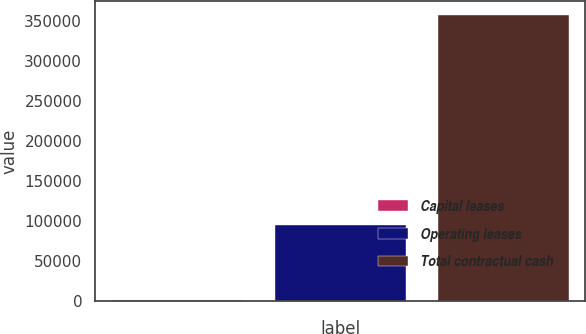Convert chart. <chart><loc_0><loc_0><loc_500><loc_500><bar_chart><fcel>Capital leases<fcel>Operating leases<fcel>Total contractual cash<nl><fcel>1557<fcel>95565<fcel>357824<nl></chart> 